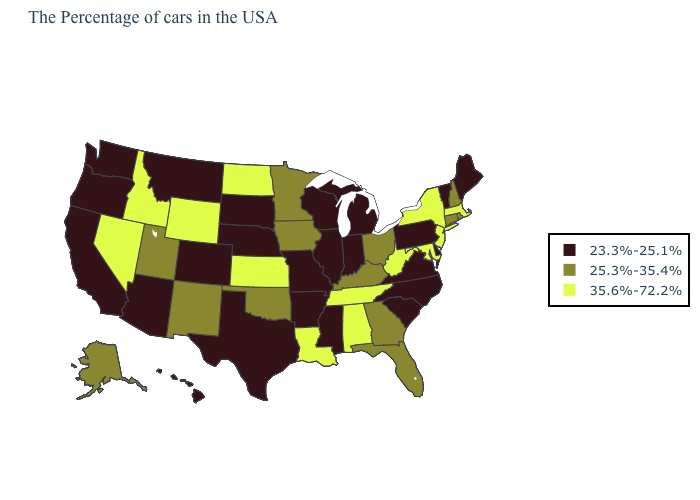How many symbols are there in the legend?
Concise answer only. 3. Does West Virginia have the highest value in the USA?
Write a very short answer. Yes. Is the legend a continuous bar?
Write a very short answer. No. Name the states that have a value in the range 35.6%-72.2%?
Quick response, please. Massachusetts, New York, New Jersey, Maryland, West Virginia, Alabama, Tennessee, Louisiana, Kansas, North Dakota, Wyoming, Idaho, Nevada. What is the highest value in states that border Arizona?
Quick response, please. 35.6%-72.2%. Is the legend a continuous bar?
Quick response, please. No. What is the highest value in states that border Alabama?
Short answer required. 35.6%-72.2%. What is the highest value in states that border North Dakota?
Give a very brief answer. 25.3%-35.4%. Name the states that have a value in the range 25.3%-35.4%?
Write a very short answer. Rhode Island, New Hampshire, Connecticut, Ohio, Florida, Georgia, Kentucky, Minnesota, Iowa, Oklahoma, New Mexico, Utah, Alaska. What is the lowest value in the USA?
Answer briefly. 23.3%-25.1%. Name the states that have a value in the range 25.3%-35.4%?
Short answer required. Rhode Island, New Hampshire, Connecticut, Ohio, Florida, Georgia, Kentucky, Minnesota, Iowa, Oklahoma, New Mexico, Utah, Alaska. How many symbols are there in the legend?
Keep it brief. 3. What is the lowest value in the MidWest?
Answer briefly. 23.3%-25.1%. Name the states that have a value in the range 35.6%-72.2%?
Keep it brief. Massachusetts, New York, New Jersey, Maryland, West Virginia, Alabama, Tennessee, Louisiana, Kansas, North Dakota, Wyoming, Idaho, Nevada. What is the lowest value in states that border North Dakota?
Quick response, please. 23.3%-25.1%. 